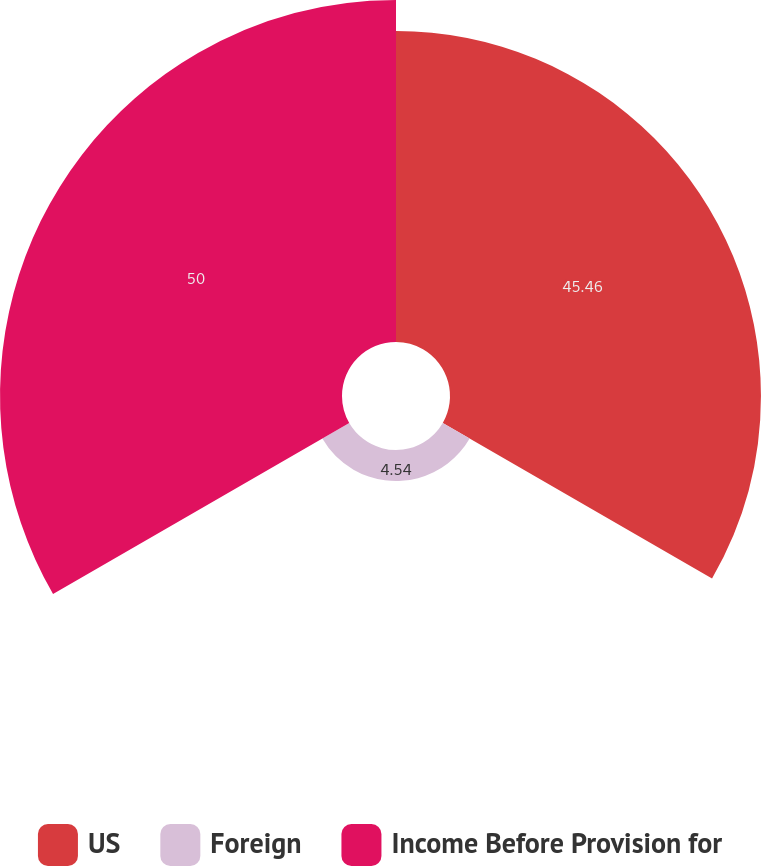<chart> <loc_0><loc_0><loc_500><loc_500><pie_chart><fcel>US<fcel>Foreign<fcel>Income Before Provision for<nl><fcel>45.46%<fcel>4.54%<fcel>50.0%<nl></chart> 